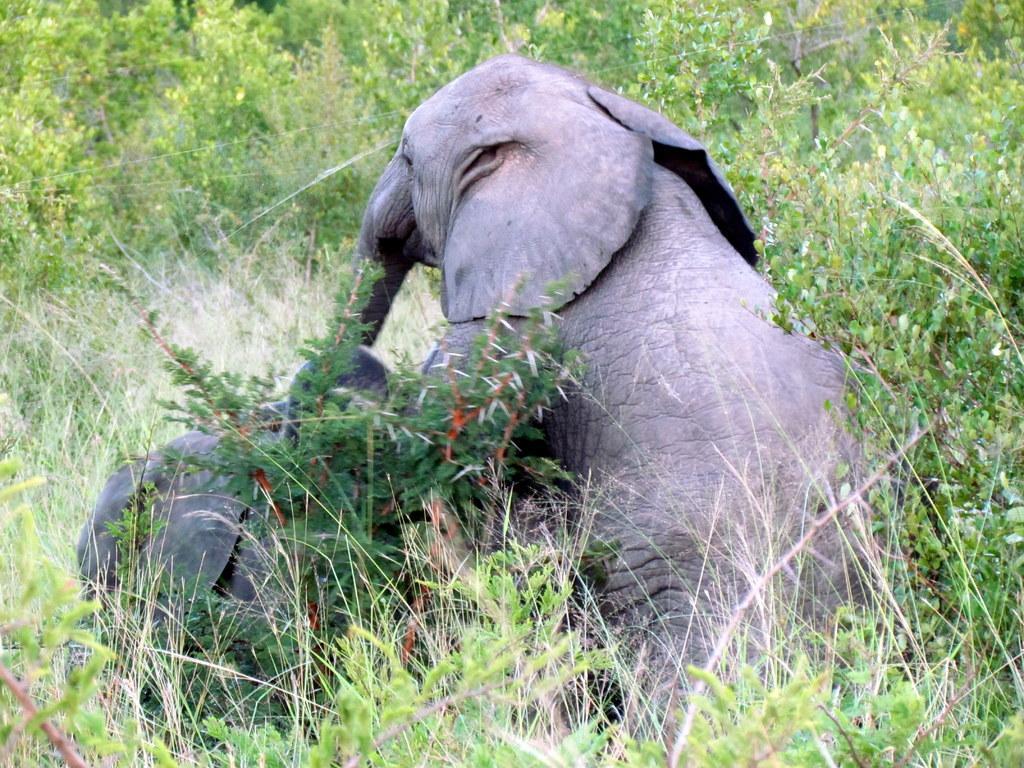Describe this image in one or two sentences. In the picture there are two elephants in between the grass. 